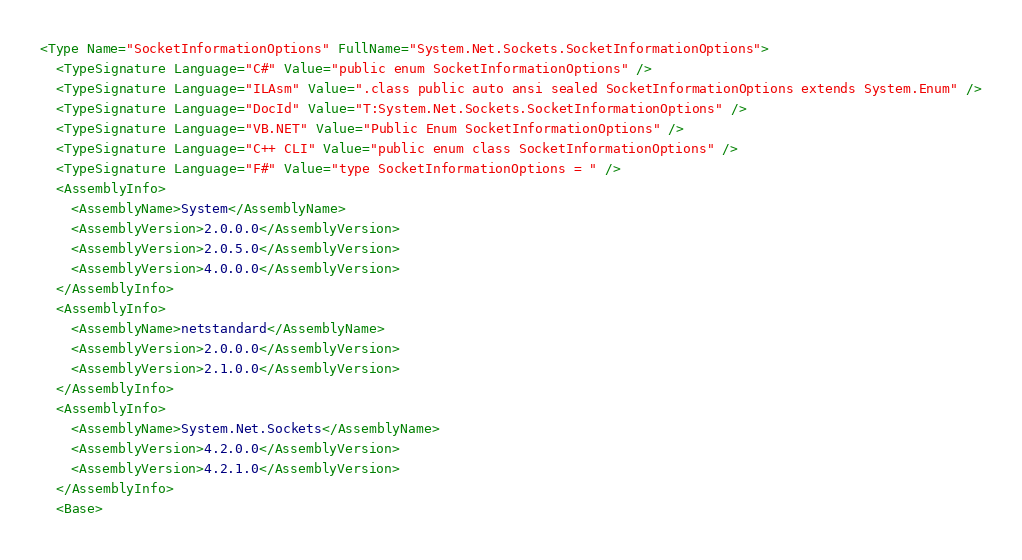<code> <loc_0><loc_0><loc_500><loc_500><_XML_><Type Name="SocketInformationOptions" FullName="System.Net.Sockets.SocketInformationOptions">
  <TypeSignature Language="C#" Value="public enum SocketInformationOptions" />
  <TypeSignature Language="ILAsm" Value=".class public auto ansi sealed SocketInformationOptions extends System.Enum" />
  <TypeSignature Language="DocId" Value="T:System.Net.Sockets.SocketInformationOptions" />
  <TypeSignature Language="VB.NET" Value="Public Enum SocketInformationOptions" />
  <TypeSignature Language="C++ CLI" Value="public enum class SocketInformationOptions" />
  <TypeSignature Language="F#" Value="type SocketInformationOptions = " />
  <AssemblyInfo>
    <AssemblyName>System</AssemblyName>
    <AssemblyVersion>2.0.0.0</AssemblyVersion>
    <AssemblyVersion>2.0.5.0</AssemblyVersion>
    <AssemblyVersion>4.0.0.0</AssemblyVersion>
  </AssemblyInfo>
  <AssemblyInfo>
    <AssemblyName>netstandard</AssemblyName>
    <AssemblyVersion>2.0.0.0</AssemblyVersion>
    <AssemblyVersion>2.1.0.0</AssemblyVersion>
  </AssemblyInfo>
  <AssemblyInfo>
    <AssemblyName>System.Net.Sockets</AssemblyName>
    <AssemblyVersion>4.2.0.0</AssemblyVersion>
    <AssemblyVersion>4.2.1.0</AssemblyVersion>
  </AssemblyInfo>
  <Base></code> 